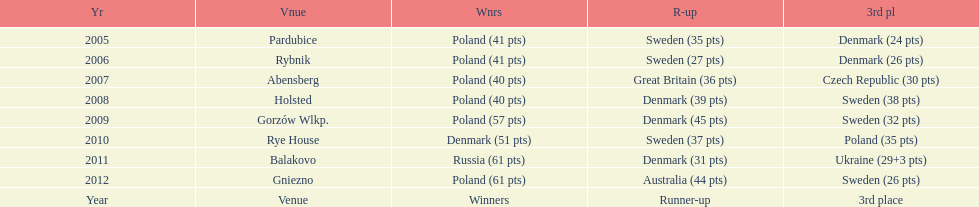Previous to 2008 how many times was sweden the runner up? 2. 